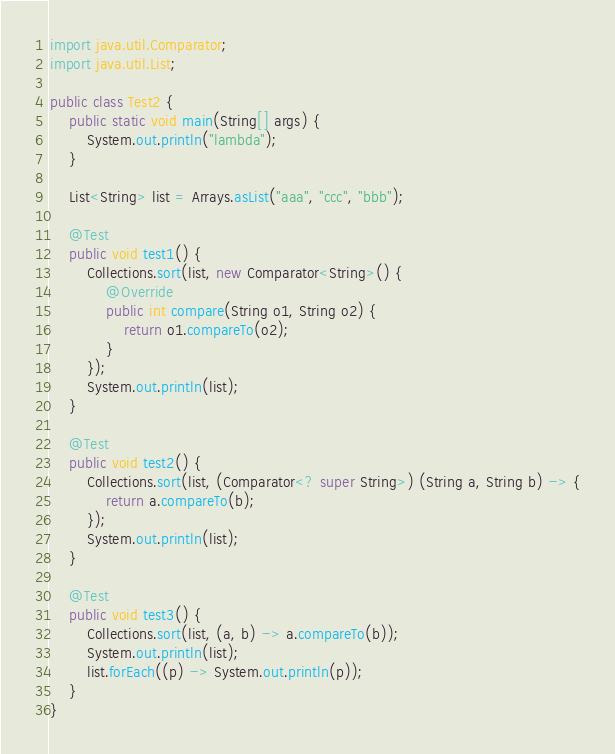<code> <loc_0><loc_0><loc_500><loc_500><_Java_>import java.util.Comparator;
import java.util.List;

public class Test2 {
    public static void main(String[] args) {
        System.out.println("lambda");
    }

    List<String> list = Arrays.asList("aaa", "ccc", "bbb");

    @Test
    public void test1() {
        Collections.sort(list, new Comparator<String>() {
            @Override
            public int compare(String o1, String o2) {
                return o1.compareTo(o2);
            }
        });
        System.out.println(list);
    }

    @Test
    public void test2() {
        Collections.sort(list, (Comparator<? super String>) (String a, String b) -> {
            return a.compareTo(b);
        });
        System.out.println(list);
    }

    @Test
    public void test3() {
        Collections.sort(list, (a, b) -> a.compareTo(b));
        System.out.println(list);
        list.forEach((p) -> System.out.println(p));
    }
}</code> 